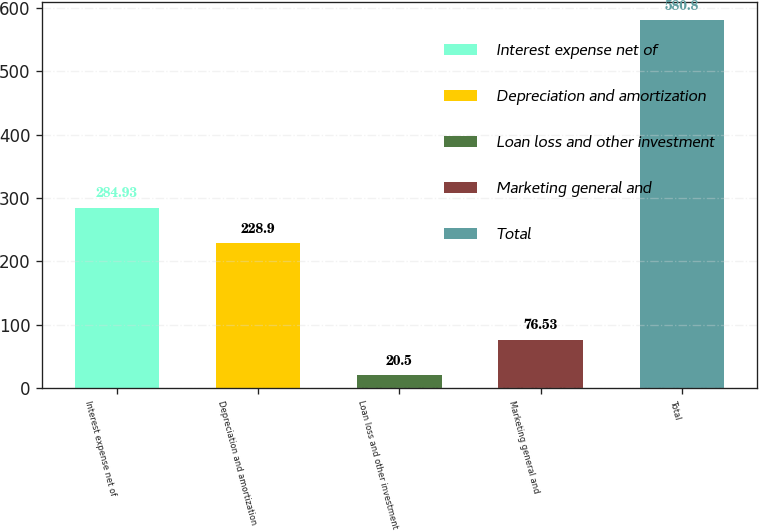Convert chart. <chart><loc_0><loc_0><loc_500><loc_500><bar_chart><fcel>Interest expense net of<fcel>Depreciation and amortization<fcel>Loan loss and other investment<fcel>Marketing general and<fcel>Total<nl><fcel>284.93<fcel>228.9<fcel>20.5<fcel>76.53<fcel>580.8<nl></chart> 